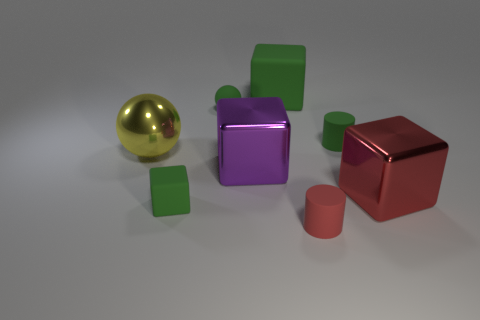The sphere that is made of the same material as the red cylinder is what size?
Make the answer very short. Small. How many objects are shiny cubes in front of the large purple metal block or small rubber objects in front of the matte ball?
Keep it short and to the point. 4. There is a green block that is behind the purple metal cube; is it the same size as the purple cube?
Your answer should be very brief. Yes. The tiny rubber object in front of the small green cube is what color?
Give a very brief answer. Red. What is the color of the other small matte thing that is the same shape as the tiny red object?
Keep it short and to the point. Green. There is a red thing behind the object that is in front of the small rubber cube; how many big red metallic blocks are in front of it?
Give a very brief answer. 0. Are there any other things that have the same material as the green sphere?
Offer a terse response. Yes. Is the number of big purple things that are behind the large purple metal cube less than the number of objects?
Keep it short and to the point. Yes. Do the big rubber thing and the metallic ball have the same color?
Offer a terse response. No. There is another metallic object that is the same shape as the big red object; what size is it?
Make the answer very short. Large. 